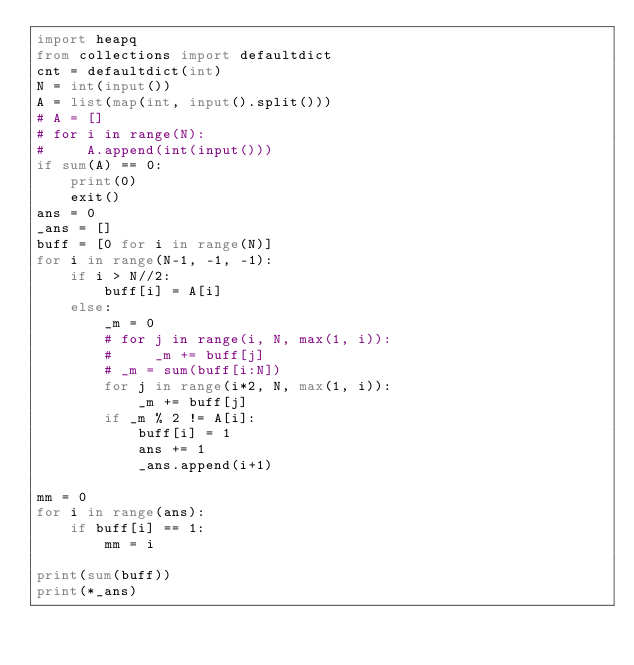<code> <loc_0><loc_0><loc_500><loc_500><_Python_>import heapq
from collections import defaultdict
cnt = defaultdict(int)
N = int(input())
A = list(map(int, input().split()))
# A = []
# for i in range(N):
#     A.append(int(input()))
if sum(A) == 0:
    print(0)
    exit()
ans = 0
_ans = []
buff = [0 for i in range(N)]
for i in range(N-1, -1, -1):
    if i > N//2:
        buff[i] = A[i]
    else:
        _m = 0
        # for j in range(i, N, max(1, i)):
        #     _m += buff[j]
        # _m = sum(buff[i:N])
        for j in range(i*2, N, max(1, i)):
            _m += buff[j]
        if _m % 2 != A[i]:
            buff[i] = 1
            ans += 1
            _ans.append(i+1)

mm = 0
for i in range(ans):
    if buff[i] == 1:
        mm = i

print(sum(buff))
print(*_ans)</code> 